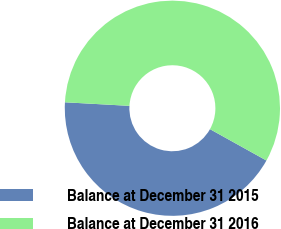Convert chart to OTSL. <chart><loc_0><loc_0><loc_500><loc_500><pie_chart><fcel>Balance at December 31 2015<fcel>Balance at December 31 2016<nl><fcel>42.81%<fcel>57.19%<nl></chart> 